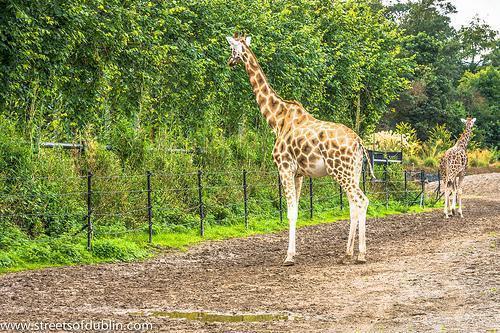How many baby giraffes are in this field?
Give a very brief answer. 1. 